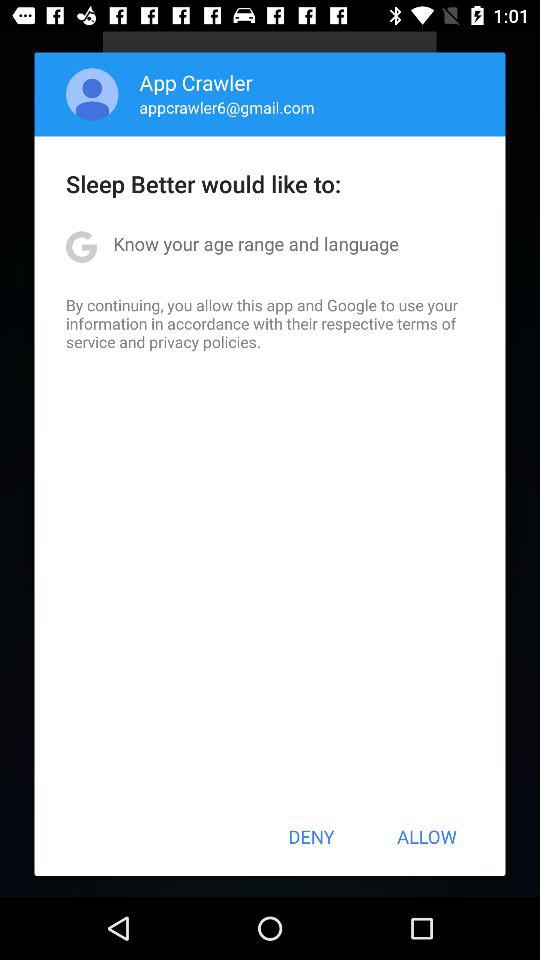What is the name of the user? The name of the user is "App Crawler". 